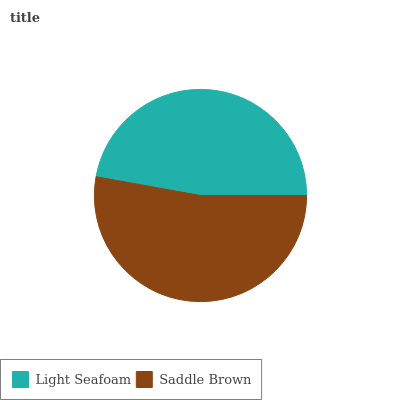Is Light Seafoam the minimum?
Answer yes or no. Yes. Is Saddle Brown the maximum?
Answer yes or no. Yes. Is Saddle Brown the minimum?
Answer yes or no. No. Is Saddle Brown greater than Light Seafoam?
Answer yes or no. Yes. Is Light Seafoam less than Saddle Brown?
Answer yes or no. Yes. Is Light Seafoam greater than Saddle Brown?
Answer yes or no. No. Is Saddle Brown less than Light Seafoam?
Answer yes or no. No. Is Saddle Brown the high median?
Answer yes or no. Yes. Is Light Seafoam the low median?
Answer yes or no. Yes. Is Light Seafoam the high median?
Answer yes or no. No. Is Saddle Brown the low median?
Answer yes or no. No. 